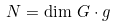Convert formula to latex. <formula><loc_0><loc_0><loc_500><loc_500>N = \dim \, G \cdot g</formula> 